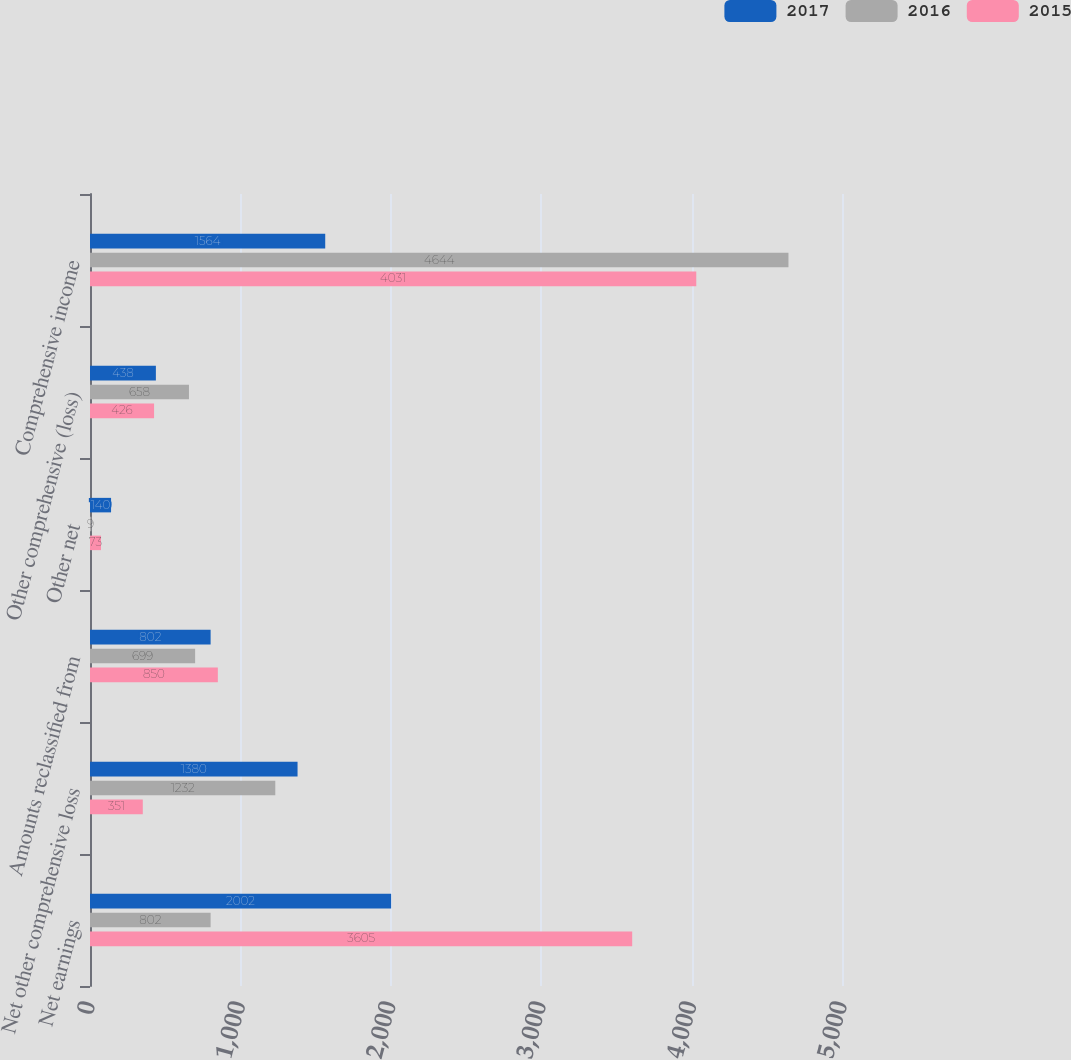Convert chart. <chart><loc_0><loc_0><loc_500><loc_500><stacked_bar_chart><ecel><fcel>Net earnings<fcel>Net other comprehensive loss<fcel>Amounts reclassified from<fcel>Other net<fcel>Other comprehensive (loss)<fcel>Comprehensive income<nl><fcel>2017<fcel>2002<fcel>1380<fcel>802<fcel>140<fcel>438<fcel>1564<nl><fcel>2016<fcel>802<fcel>1232<fcel>699<fcel>9<fcel>658<fcel>4644<nl><fcel>2015<fcel>3605<fcel>351<fcel>850<fcel>73<fcel>426<fcel>4031<nl></chart> 